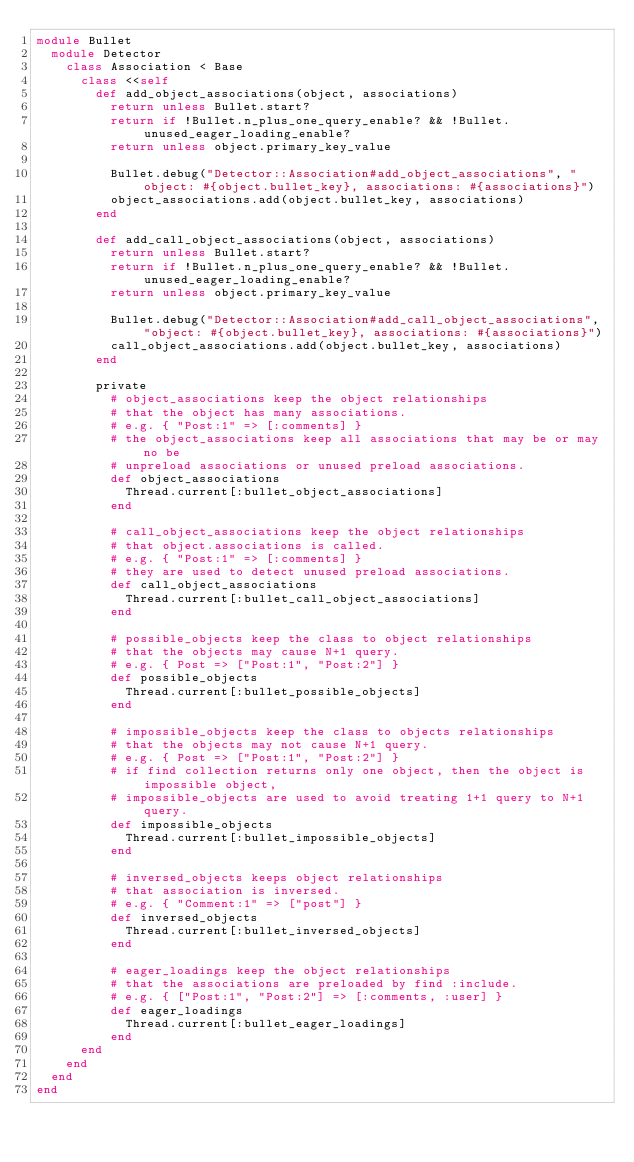<code> <loc_0><loc_0><loc_500><loc_500><_Ruby_>module Bullet
  module Detector
    class Association < Base
      class <<self
        def add_object_associations(object, associations)
          return unless Bullet.start?
          return if !Bullet.n_plus_one_query_enable? && !Bullet.unused_eager_loading_enable?
          return unless object.primary_key_value

          Bullet.debug("Detector::Association#add_object_associations", "object: #{object.bullet_key}, associations: #{associations}")
          object_associations.add(object.bullet_key, associations)
        end

        def add_call_object_associations(object, associations)
          return unless Bullet.start?
          return if !Bullet.n_plus_one_query_enable? && !Bullet.unused_eager_loading_enable?
          return unless object.primary_key_value

          Bullet.debug("Detector::Association#add_call_object_associations", "object: #{object.bullet_key}, associations: #{associations}")
          call_object_associations.add(object.bullet_key, associations)
        end

        private
          # object_associations keep the object relationships
          # that the object has many associations.
          # e.g. { "Post:1" => [:comments] }
          # the object_associations keep all associations that may be or may no be
          # unpreload associations or unused preload associations.
          def object_associations
            Thread.current[:bullet_object_associations]
          end

          # call_object_associations keep the object relationships
          # that object.associations is called.
          # e.g. { "Post:1" => [:comments] }
          # they are used to detect unused preload associations.
          def call_object_associations
            Thread.current[:bullet_call_object_associations]
          end

          # possible_objects keep the class to object relationships
          # that the objects may cause N+1 query.
          # e.g. { Post => ["Post:1", "Post:2"] }
          def possible_objects
            Thread.current[:bullet_possible_objects]
          end

          # impossible_objects keep the class to objects relationships
          # that the objects may not cause N+1 query.
          # e.g. { Post => ["Post:1", "Post:2"] }
          # if find collection returns only one object, then the object is impossible object,
          # impossible_objects are used to avoid treating 1+1 query to N+1 query.
          def impossible_objects
            Thread.current[:bullet_impossible_objects]
          end

          # inversed_objects keeps object relationships
          # that association is inversed.
          # e.g. { "Comment:1" => ["post"] }
          def inversed_objects
            Thread.current[:bullet_inversed_objects]
          end

          # eager_loadings keep the object relationships
          # that the associations are preloaded by find :include.
          # e.g. { ["Post:1", "Post:2"] => [:comments, :user] }
          def eager_loadings
            Thread.current[:bullet_eager_loadings]
          end
      end
    end
  end
end
</code> 